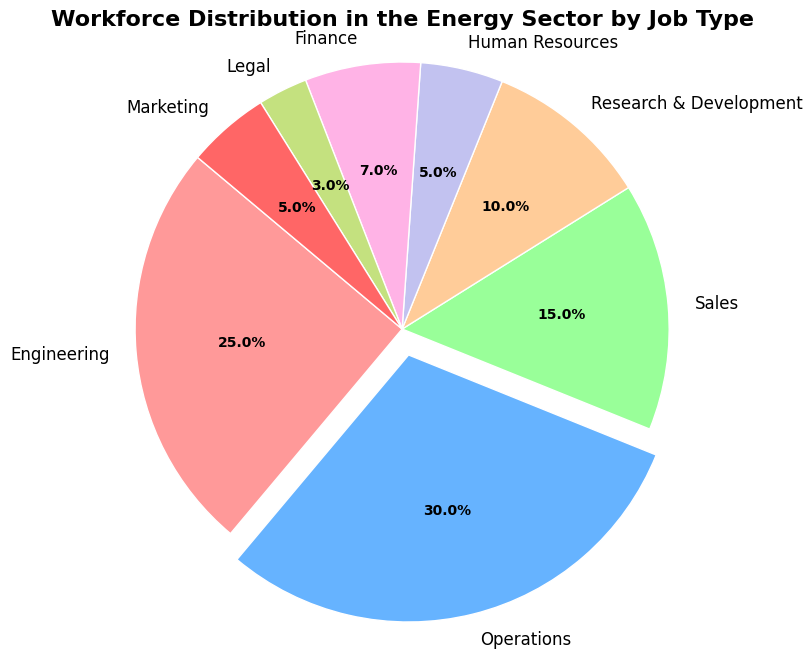What job type has the largest workforce percentage according to the pie chart? The pie chart highlights the job type with the largest workforce percentage by slightly separating (exploding) its wedge from the rest. Upon examining the chart, it is evident that the "Operations" wedge is the largest and the one that's separated.
Answer: Operations Which job types have the same workforce percentage in the energy sector? By examining the pie chart, we can see that "Human Resources" and "Marketing" wedges are similar in size. The labels confirm that both sectors each have 5% of the workforce.
Answer: Human Resources and Marketing What is the total percentage for the workforce in Engineering, Sales, and Finance combined? First, locate each job type on the pie chart: "Engineering" has 25%, "Sales" has 15%, and "Finance" has 7%. Adding these percentages together yields 25 + 15 + 7 = 47%.
Answer: 47% How does the workforce percentage in Research & Development compare to that in Legal? According to the pie chart, "Research & Development" has 10% of the workforce, while "Legal" has 3%. Therefore, the workforce percentage in Research & Development is greater than in Legal.
Answer: Research & Development is greater than Legal If we were to reallocate 2% from Operations to Research & Development, what would the new percentages be for each? Starting with "Operations" at 30% and "Research & Development" at 10%, subtract 2% from Operations, resulting in 30% - 2% = 28%. Add this 2% to Research & Development, resulting in 10% + 2% = 12%.
Answer: Operations: 28%, Research & Development: 12% What is the difference in workforce percentage between Engineering and Sales? According to the pie chart, Engineering has 25% of the workforce while Sales has 15%. Subtracting 15% from 25% provides 25 - 15 = 10%.
Answer: 10% Which job type has a smaller workforce percentage than Finance but larger than Legal? From the chart, identify that Finance has 7%. The only job type that fits between these given percentages (larger than 3% Legal and smaller than 7% Finance) is Human Resources with 5%.
Answer: Human Resources What are the visual distinctions used to highlight the job type with the highest percentage? The pie chart distinguishes the job type with the highest percentage by "exploding" its slice slightly away from the others, as well as using color to differentiate it.
Answer: Exploded slice and color What is the cumulative percentage of the smallest three job types? According to the pie chart data, the smallest job types are Legal (3%), Human Resources (5%), and Marketing (5%). Adding these together yields 3 + 5 + 5 = 13%.
Answer: 13% 